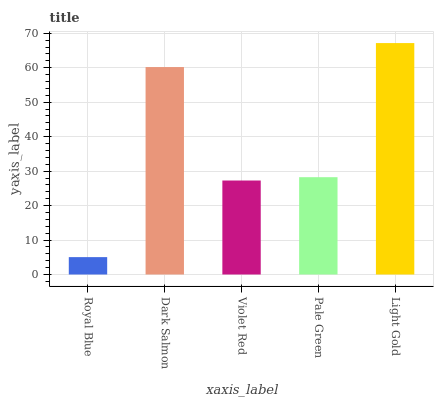Is Dark Salmon the minimum?
Answer yes or no. No. Is Dark Salmon the maximum?
Answer yes or no. No. Is Dark Salmon greater than Royal Blue?
Answer yes or no. Yes. Is Royal Blue less than Dark Salmon?
Answer yes or no. Yes. Is Royal Blue greater than Dark Salmon?
Answer yes or no. No. Is Dark Salmon less than Royal Blue?
Answer yes or no. No. Is Pale Green the high median?
Answer yes or no. Yes. Is Pale Green the low median?
Answer yes or no. Yes. Is Royal Blue the high median?
Answer yes or no. No. Is Dark Salmon the low median?
Answer yes or no. No. 